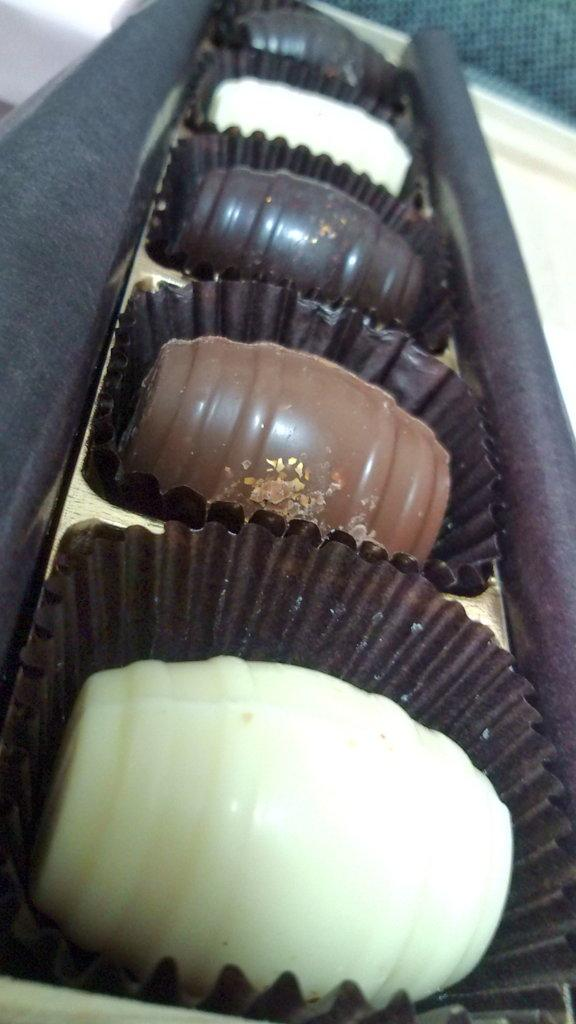What type of food is visible in the image? There are chocolates in the image. How are the chocolates packaged? The chocolates are in a wrapper. Where is the calculator placed in the image? There is no calculator present in the image. 